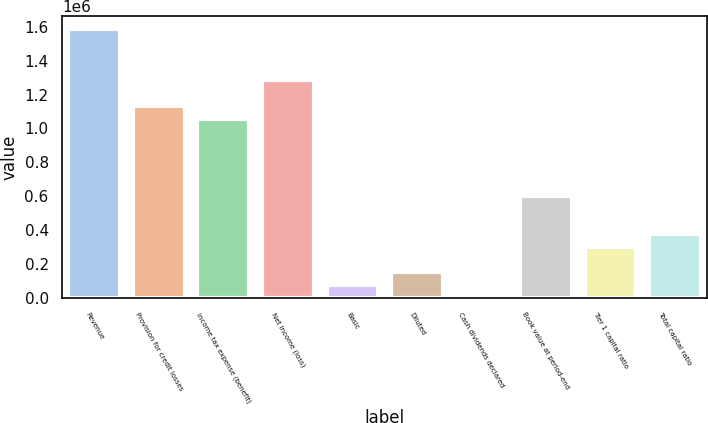Convert chart. <chart><loc_0><loc_0><loc_500><loc_500><bar_chart><fcel>Revenue<fcel>Provision for credit losses<fcel>Income tax expense (benefit)<fcel>Net income (loss)<fcel>Basic<fcel>Diluted<fcel>Cash dividends declared<fcel>Book value at period-end<fcel>Tier 1 capital ratio<fcel>Total capital ratio<nl><fcel>1.58583e+06<fcel>1.13273e+06<fcel>1.05722e+06<fcel>1.28377e+06<fcel>75515.9<fcel>151031<fcel>0.34<fcel>604125<fcel>302063<fcel>377578<nl></chart> 